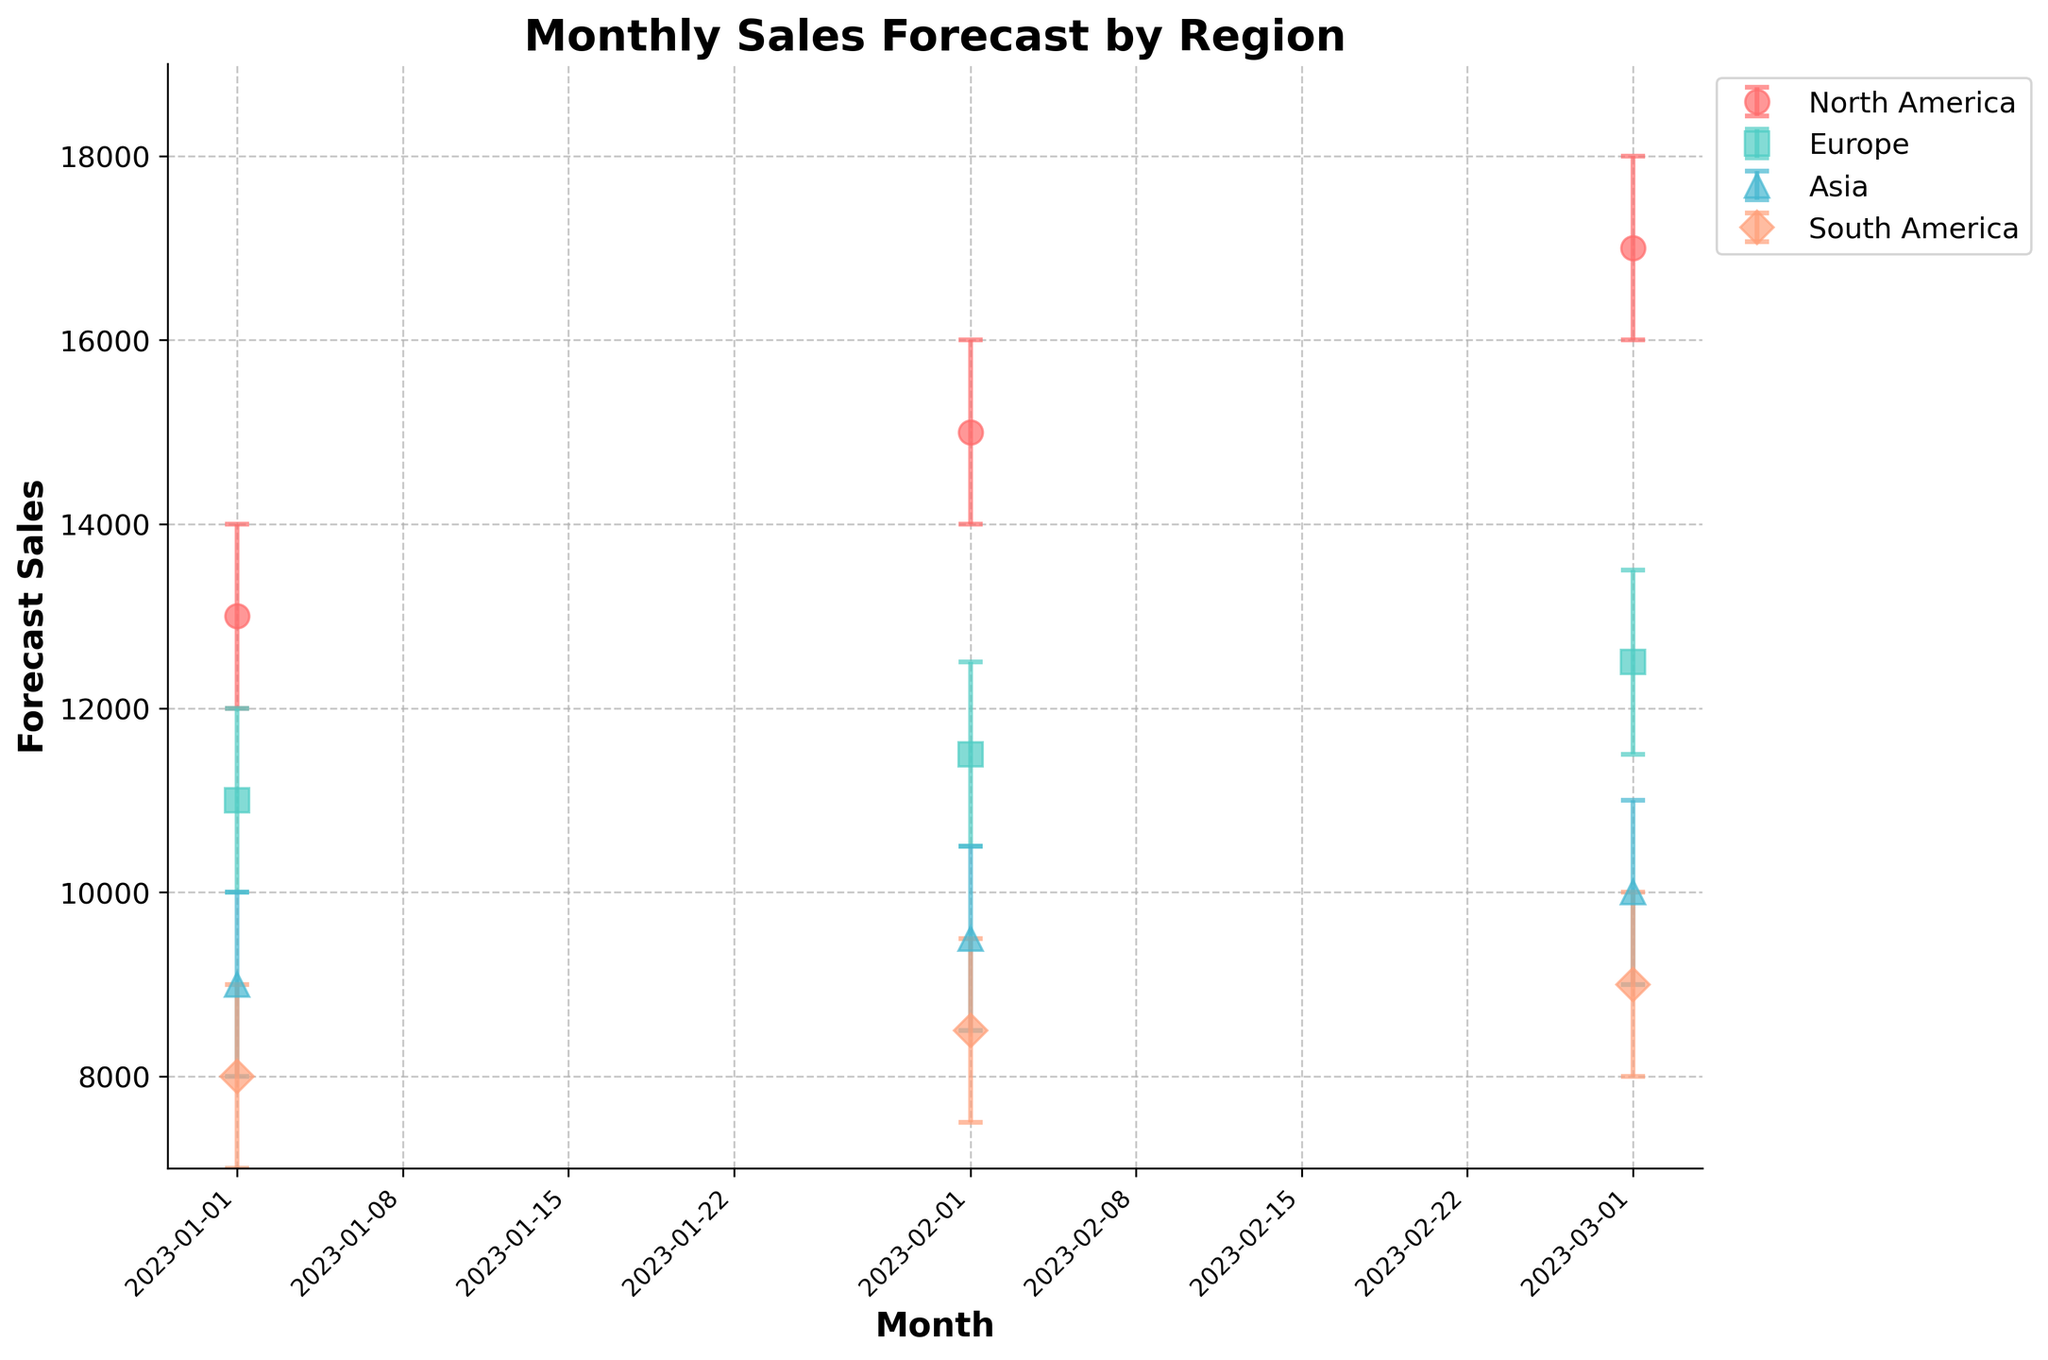Which region has the highest forecast sales in March 2023? Look at the forecast sales values for March 2023 across all regions. North America has the highest forecast sales at 17000.
Answer: North America What is the title of the figure? The title is located at the top of the figure, clearly stating the subject of the data visualization.
Answer: Monthly Sales Forecast by Region Which region shows the smallest uncertainty in its forecast sales for February 2023? The uncertainty can be determined by the length of the error bars. Europe has the smallest error bars in February 2023.
Answer: Europe What is the average forecast sales for Europe across the months? Sum the forecast sales for Europe from January to March and divide by the number of data points: (11000 + 11500 + 12500) / 3 = 11666.67.
Answer: 11666.67 Compare the forecast sales for Asia and South America in January 2023. Which region has higher forecast sales? Look at the forecast sales value for January 2023 for both regions. Asia has 9000, while South America has 8000. Asia has higher forecast sales.
Answer: Asia How many months of data are represented in the figure? Count the data points along the x-axis. There are three months represented: January, February, and March 2023.
Answer: 3 Which region has the widest confidence interval in January 2023? The width of the confidence interval is the distance between the upper and lower bounds of the error bars. South America has the widest interval from 7000 to 9000.
Answer: South America What is the pattern of forecast sales for North America from January to March 2023? Observe the trend of the forecast sales for North America from January to March. The values are increasing: 13000 in January, 15000 in February, and 17000 in March.
Answer: Increasing What is the difference between the highest and lowest forecast sales for February 2023? The highest forecast sales in February 2023 is from North America (15000), and the lowest is from South America (8500). The difference is 15000 - 8500 = 6500.
Answer: 6500 By how much do the forecast sales for South America increase from January to March 2023? Subtract the forecast sales value in January from the value in March: 9000 - 8000 = 1000.
Answer: 1000 